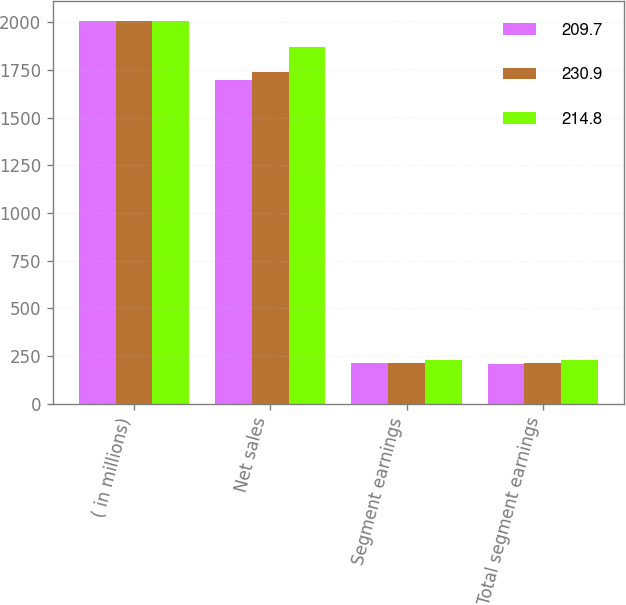Convert chart. <chart><loc_0><loc_0><loc_500><loc_500><stacked_bar_chart><ecel><fcel>( in millions)<fcel>Net sales<fcel>Segment earnings<fcel>Total segment earnings<nl><fcel>209.7<fcel>2010<fcel>1697.6<fcel>212.9<fcel>209.7<nl><fcel>230.9<fcel>2009<fcel>1739.5<fcel>214.8<fcel>214.8<nl><fcel>214.8<fcel>2008<fcel>1868.7<fcel>230.9<fcel>230.9<nl></chart> 